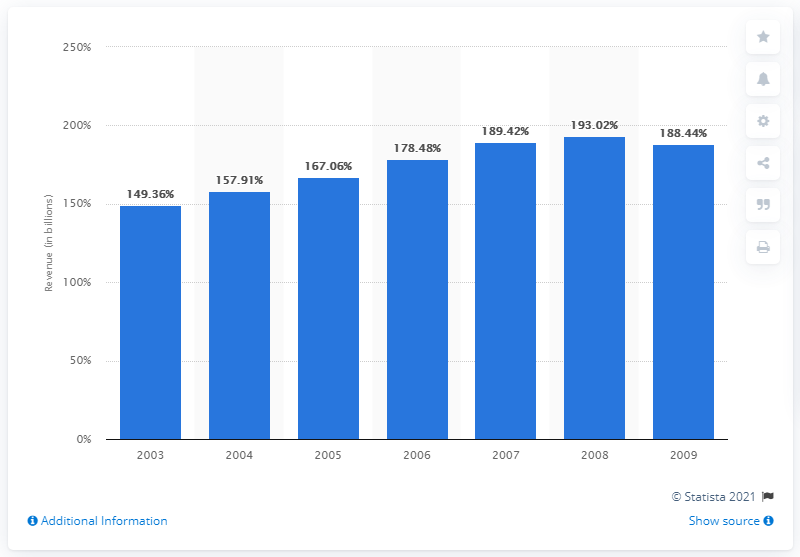List a handful of essential elements in this visual. In 2003, the total revenue for the arts, entertainment, and recreation industry was $149.36 billion. 